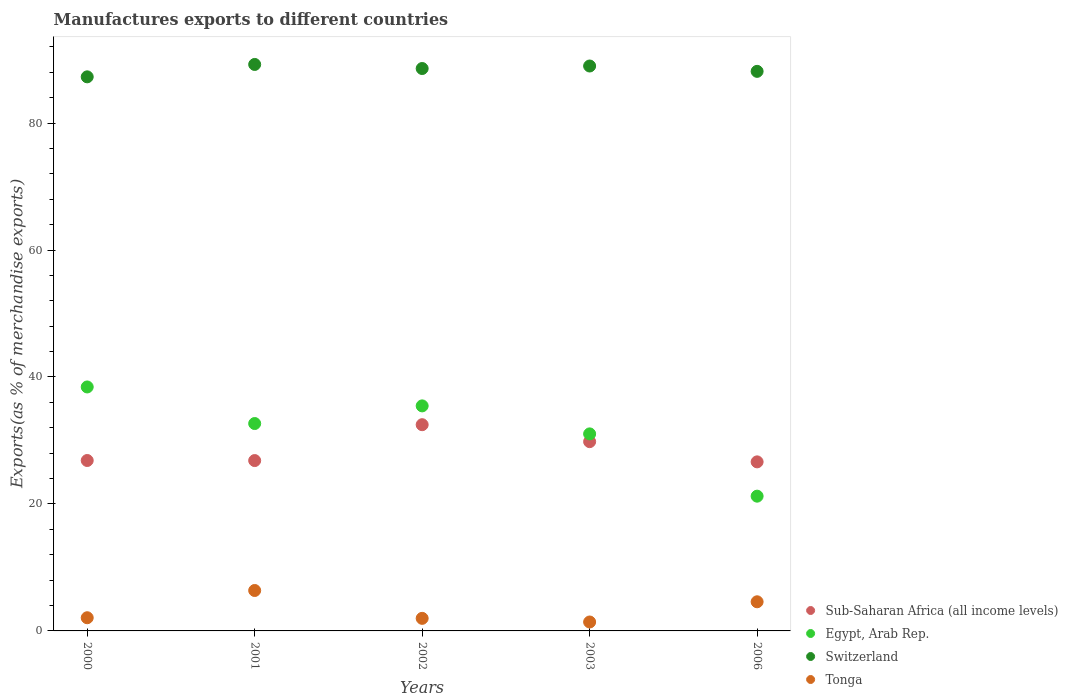How many different coloured dotlines are there?
Make the answer very short. 4. Is the number of dotlines equal to the number of legend labels?
Your response must be concise. Yes. What is the percentage of exports to different countries in Egypt, Arab Rep. in 2000?
Offer a terse response. 38.43. Across all years, what is the maximum percentage of exports to different countries in Tonga?
Offer a terse response. 6.37. Across all years, what is the minimum percentage of exports to different countries in Sub-Saharan Africa (all income levels)?
Provide a short and direct response. 26.63. In which year was the percentage of exports to different countries in Sub-Saharan Africa (all income levels) maximum?
Offer a terse response. 2002. What is the total percentage of exports to different countries in Tonga in the graph?
Provide a succinct answer. 16.42. What is the difference between the percentage of exports to different countries in Sub-Saharan Africa (all income levels) in 2002 and that in 2006?
Ensure brevity in your answer.  5.85. What is the difference between the percentage of exports to different countries in Tonga in 2003 and the percentage of exports to different countries in Switzerland in 2000?
Make the answer very short. -85.87. What is the average percentage of exports to different countries in Tonga per year?
Provide a succinct answer. 3.28. In the year 2003, what is the difference between the percentage of exports to different countries in Egypt, Arab Rep. and percentage of exports to different countries in Switzerland?
Your answer should be very brief. -57.95. In how many years, is the percentage of exports to different countries in Sub-Saharan Africa (all income levels) greater than 36 %?
Offer a very short reply. 0. What is the ratio of the percentage of exports to different countries in Switzerland in 2000 to that in 2003?
Your answer should be compact. 0.98. Is the difference between the percentage of exports to different countries in Egypt, Arab Rep. in 2001 and 2002 greater than the difference between the percentage of exports to different countries in Switzerland in 2001 and 2002?
Provide a short and direct response. No. What is the difference between the highest and the second highest percentage of exports to different countries in Sub-Saharan Africa (all income levels)?
Keep it short and to the point. 2.67. What is the difference between the highest and the lowest percentage of exports to different countries in Egypt, Arab Rep.?
Offer a very short reply. 17.2. In how many years, is the percentage of exports to different countries in Sub-Saharan Africa (all income levels) greater than the average percentage of exports to different countries in Sub-Saharan Africa (all income levels) taken over all years?
Make the answer very short. 2. Is the sum of the percentage of exports to different countries in Switzerland in 2000 and 2002 greater than the maximum percentage of exports to different countries in Sub-Saharan Africa (all income levels) across all years?
Give a very brief answer. Yes. Is it the case that in every year, the sum of the percentage of exports to different countries in Egypt, Arab Rep. and percentage of exports to different countries in Sub-Saharan Africa (all income levels)  is greater than the percentage of exports to different countries in Tonga?
Make the answer very short. Yes. Is the percentage of exports to different countries in Sub-Saharan Africa (all income levels) strictly less than the percentage of exports to different countries in Tonga over the years?
Make the answer very short. No. Are the values on the major ticks of Y-axis written in scientific E-notation?
Ensure brevity in your answer.  No. Does the graph contain any zero values?
Provide a succinct answer. No. Does the graph contain grids?
Ensure brevity in your answer.  No. What is the title of the graph?
Offer a terse response. Manufactures exports to different countries. What is the label or title of the X-axis?
Keep it short and to the point. Years. What is the label or title of the Y-axis?
Your answer should be very brief. Exports(as % of merchandise exports). What is the Exports(as % of merchandise exports) of Sub-Saharan Africa (all income levels) in 2000?
Provide a succinct answer. 26.84. What is the Exports(as % of merchandise exports) in Egypt, Arab Rep. in 2000?
Make the answer very short. 38.43. What is the Exports(as % of merchandise exports) in Switzerland in 2000?
Offer a very short reply. 87.28. What is the Exports(as % of merchandise exports) in Tonga in 2000?
Ensure brevity in your answer.  2.08. What is the Exports(as % of merchandise exports) of Sub-Saharan Africa (all income levels) in 2001?
Ensure brevity in your answer.  26.83. What is the Exports(as % of merchandise exports) in Egypt, Arab Rep. in 2001?
Offer a terse response. 32.67. What is the Exports(as % of merchandise exports) in Switzerland in 2001?
Offer a very short reply. 89.23. What is the Exports(as % of merchandise exports) of Tonga in 2001?
Ensure brevity in your answer.  6.37. What is the Exports(as % of merchandise exports) of Sub-Saharan Africa (all income levels) in 2002?
Your answer should be very brief. 32.48. What is the Exports(as % of merchandise exports) in Egypt, Arab Rep. in 2002?
Give a very brief answer. 35.45. What is the Exports(as % of merchandise exports) of Switzerland in 2002?
Keep it short and to the point. 88.59. What is the Exports(as % of merchandise exports) in Tonga in 2002?
Make the answer very short. 1.98. What is the Exports(as % of merchandise exports) in Sub-Saharan Africa (all income levels) in 2003?
Keep it short and to the point. 29.81. What is the Exports(as % of merchandise exports) of Egypt, Arab Rep. in 2003?
Your response must be concise. 31.04. What is the Exports(as % of merchandise exports) in Switzerland in 2003?
Offer a very short reply. 88.98. What is the Exports(as % of merchandise exports) in Tonga in 2003?
Offer a terse response. 1.41. What is the Exports(as % of merchandise exports) in Sub-Saharan Africa (all income levels) in 2006?
Your answer should be very brief. 26.63. What is the Exports(as % of merchandise exports) of Egypt, Arab Rep. in 2006?
Make the answer very short. 21.23. What is the Exports(as % of merchandise exports) in Switzerland in 2006?
Offer a terse response. 88.14. What is the Exports(as % of merchandise exports) in Tonga in 2006?
Keep it short and to the point. 4.59. Across all years, what is the maximum Exports(as % of merchandise exports) of Sub-Saharan Africa (all income levels)?
Make the answer very short. 32.48. Across all years, what is the maximum Exports(as % of merchandise exports) in Egypt, Arab Rep.?
Your answer should be compact. 38.43. Across all years, what is the maximum Exports(as % of merchandise exports) in Switzerland?
Provide a short and direct response. 89.23. Across all years, what is the maximum Exports(as % of merchandise exports) of Tonga?
Provide a succinct answer. 6.37. Across all years, what is the minimum Exports(as % of merchandise exports) of Sub-Saharan Africa (all income levels)?
Provide a short and direct response. 26.63. Across all years, what is the minimum Exports(as % of merchandise exports) of Egypt, Arab Rep.?
Give a very brief answer. 21.23. Across all years, what is the minimum Exports(as % of merchandise exports) in Switzerland?
Give a very brief answer. 87.28. Across all years, what is the minimum Exports(as % of merchandise exports) of Tonga?
Give a very brief answer. 1.41. What is the total Exports(as % of merchandise exports) of Sub-Saharan Africa (all income levels) in the graph?
Ensure brevity in your answer.  142.6. What is the total Exports(as % of merchandise exports) in Egypt, Arab Rep. in the graph?
Give a very brief answer. 158.81. What is the total Exports(as % of merchandise exports) in Switzerland in the graph?
Give a very brief answer. 442.22. What is the total Exports(as % of merchandise exports) in Tonga in the graph?
Make the answer very short. 16.42. What is the difference between the Exports(as % of merchandise exports) of Sub-Saharan Africa (all income levels) in 2000 and that in 2001?
Your answer should be very brief. 0.01. What is the difference between the Exports(as % of merchandise exports) of Egypt, Arab Rep. in 2000 and that in 2001?
Give a very brief answer. 5.76. What is the difference between the Exports(as % of merchandise exports) of Switzerland in 2000 and that in 2001?
Your answer should be very brief. -1.95. What is the difference between the Exports(as % of merchandise exports) of Tonga in 2000 and that in 2001?
Ensure brevity in your answer.  -4.29. What is the difference between the Exports(as % of merchandise exports) of Sub-Saharan Africa (all income levels) in 2000 and that in 2002?
Your response must be concise. -5.64. What is the difference between the Exports(as % of merchandise exports) of Egypt, Arab Rep. in 2000 and that in 2002?
Provide a short and direct response. 2.98. What is the difference between the Exports(as % of merchandise exports) in Switzerland in 2000 and that in 2002?
Offer a very short reply. -1.31. What is the difference between the Exports(as % of merchandise exports) of Tonga in 2000 and that in 2002?
Keep it short and to the point. 0.1. What is the difference between the Exports(as % of merchandise exports) of Sub-Saharan Africa (all income levels) in 2000 and that in 2003?
Offer a terse response. -2.97. What is the difference between the Exports(as % of merchandise exports) of Egypt, Arab Rep. in 2000 and that in 2003?
Give a very brief answer. 7.39. What is the difference between the Exports(as % of merchandise exports) in Switzerland in 2000 and that in 2003?
Your answer should be very brief. -1.71. What is the difference between the Exports(as % of merchandise exports) of Tonga in 2000 and that in 2003?
Your response must be concise. 0.67. What is the difference between the Exports(as % of merchandise exports) in Sub-Saharan Africa (all income levels) in 2000 and that in 2006?
Your answer should be compact. 0.22. What is the difference between the Exports(as % of merchandise exports) of Egypt, Arab Rep. in 2000 and that in 2006?
Give a very brief answer. 17.2. What is the difference between the Exports(as % of merchandise exports) in Switzerland in 2000 and that in 2006?
Your answer should be very brief. -0.86. What is the difference between the Exports(as % of merchandise exports) in Tonga in 2000 and that in 2006?
Offer a terse response. -2.51. What is the difference between the Exports(as % of merchandise exports) of Sub-Saharan Africa (all income levels) in 2001 and that in 2002?
Provide a short and direct response. -5.65. What is the difference between the Exports(as % of merchandise exports) of Egypt, Arab Rep. in 2001 and that in 2002?
Keep it short and to the point. -2.78. What is the difference between the Exports(as % of merchandise exports) of Switzerland in 2001 and that in 2002?
Your answer should be very brief. 0.64. What is the difference between the Exports(as % of merchandise exports) in Tonga in 2001 and that in 2002?
Your response must be concise. 4.39. What is the difference between the Exports(as % of merchandise exports) of Sub-Saharan Africa (all income levels) in 2001 and that in 2003?
Your answer should be very brief. -2.98. What is the difference between the Exports(as % of merchandise exports) in Egypt, Arab Rep. in 2001 and that in 2003?
Offer a very short reply. 1.63. What is the difference between the Exports(as % of merchandise exports) in Switzerland in 2001 and that in 2003?
Your answer should be very brief. 0.24. What is the difference between the Exports(as % of merchandise exports) of Tonga in 2001 and that in 2003?
Offer a very short reply. 4.96. What is the difference between the Exports(as % of merchandise exports) of Sub-Saharan Africa (all income levels) in 2001 and that in 2006?
Make the answer very short. 0.2. What is the difference between the Exports(as % of merchandise exports) of Egypt, Arab Rep. in 2001 and that in 2006?
Your answer should be compact. 11.44. What is the difference between the Exports(as % of merchandise exports) of Switzerland in 2001 and that in 2006?
Provide a short and direct response. 1.09. What is the difference between the Exports(as % of merchandise exports) in Tonga in 2001 and that in 2006?
Offer a terse response. 1.78. What is the difference between the Exports(as % of merchandise exports) in Sub-Saharan Africa (all income levels) in 2002 and that in 2003?
Your answer should be compact. 2.67. What is the difference between the Exports(as % of merchandise exports) in Egypt, Arab Rep. in 2002 and that in 2003?
Your response must be concise. 4.41. What is the difference between the Exports(as % of merchandise exports) of Switzerland in 2002 and that in 2003?
Your answer should be very brief. -0.4. What is the difference between the Exports(as % of merchandise exports) in Tonga in 2002 and that in 2003?
Provide a short and direct response. 0.57. What is the difference between the Exports(as % of merchandise exports) in Sub-Saharan Africa (all income levels) in 2002 and that in 2006?
Ensure brevity in your answer.  5.85. What is the difference between the Exports(as % of merchandise exports) in Egypt, Arab Rep. in 2002 and that in 2006?
Your response must be concise. 14.22. What is the difference between the Exports(as % of merchandise exports) in Switzerland in 2002 and that in 2006?
Offer a very short reply. 0.45. What is the difference between the Exports(as % of merchandise exports) in Tonga in 2002 and that in 2006?
Give a very brief answer. -2.61. What is the difference between the Exports(as % of merchandise exports) in Sub-Saharan Africa (all income levels) in 2003 and that in 2006?
Provide a short and direct response. 3.18. What is the difference between the Exports(as % of merchandise exports) of Egypt, Arab Rep. in 2003 and that in 2006?
Your answer should be compact. 9.81. What is the difference between the Exports(as % of merchandise exports) in Switzerland in 2003 and that in 2006?
Your answer should be compact. 0.84. What is the difference between the Exports(as % of merchandise exports) in Tonga in 2003 and that in 2006?
Ensure brevity in your answer.  -3.18. What is the difference between the Exports(as % of merchandise exports) of Sub-Saharan Africa (all income levels) in 2000 and the Exports(as % of merchandise exports) of Egypt, Arab Rep. in 2001?
Make the answer very short. -5.82. What is the difference between the Exports(as % of merchandise exports) in Sub-Saharan Africa (all income levels) in 2000 and the Exports(as % of merchandise exports) in Switzerland in 2001?
Offer a terse response. -62.38. What is the difference between the Exports(as % of merchandise exports) in Sub-Saharan Africa (all income levels) in 2000 and the Exports(as % of merchandise exports) in Tonga in 2001?
Give a very brief answer. 20.48. What is the difference between the Exports(as % of merchandise exports) of Egypt, Arab Rep. in 2000 and the Exports(as % of merchandise exports) of Switzerland in 2001?
Your response must be concise. -50.8. What is the difference between the Exports(as % of merchandise exports) of Egypt, Arab Rep. in 2000 and the Exports(as % of merchandise exports) of Tonga in 2001?
Your answer should be compact. 32.06. What is the difference between the Exports(as % of merchandise exports) in Switzerland in 2000 and the Exports(as % of merchandise exports) in Tonga in 2001?
Provide a succinct answer. 80.91. What is the difference between the Exports(as % of merchandise exports) in Sub-Saharan Africa (all income levels) in 2000 and the Exports(as % of merchandise exports) in Egypt, Arab Rep. in 2002?
Offer a terse response. -8.6. What is the difference between the Exports(as % of merchandise exports) of Sub-Saharan Africa (all income levels) in 2000 and the Exports(as % of merchandise exports) of Switzerland in 2002?
Ensure brevity in your answer.  -61.74. What is the difference between the Exports(as % of merchandise exports) in Sub-Saharan Africa (all income levels) in 2000 and the Exports(as % of merchandise exports) in Tonga in 2002?
Your answer should be very brief. 24.87. What is the difference between the Exports(as % of merchandise exports) in Egypt, Arab Rep. in 2000 and the Exports(as % of merchandise exports) in Switzerland in 2002?
Offer a very short reply. -50.16. What is the difference between the Exports(as % of merchandise exports) in Egypt, Arab Rep. in 2000 and the Exports(as % of merchandise exports) in Tonga in 2002?
Offer a very short reply. 36.45. What is the difference between the Exports(as % of merchandise exports) of Switzerland in 2000 and the Exports(as % of merchandise exports) of Tonga in 2002?
Give a very brief answer. 85.3. What is the difference between the Exports(as % of merchandise exports) of Sub-Saharan Africa (all income levels) in 2000 and the Exports(as % of merchandise exports) of Egypt, Arab Rep. in 2003?
Give a very brief answer. -4.19. What is the difference between the Exports(as % of merchandise exports) in Sub-Saharan Africa (all income levels) in 2000 and the Exports(as % of merchandise exports) in Switzerland in 2003?
Offer a very short reply. -62.14. What is the difference between the Exports(as % of merchandise exports) of Sub-Saharan Africa (all income levels) in 2000 and the Exports(as % of merchandise exports) of Tonga in 2003?
Provide a short and direct response. 25.44. What is the difference between the Exports(as % of merchandise exports) in Egypt, Arab Rep. in 2000 and the Exports(as % of merchandise exports) in Switzerland in 2003?
Provide a short and direct response. -50.56. What is the difference between the Exports(as % of merchandise exports) of Egypt, Arab Rep. in 2000 and the Exports(as % of merchandise exports) of Tonga in 2003?
Provide a short and direct response. 37.02. What is the difference between the Exports(as % of merchandise exports) of Switzerland in 2000 and the Exports(as % of merchandise exports) of Tonga in 2003?
Offer a terse response. 85.87. What is the difference between the Exports(as % of merchandise exports) in Sub-Saharan Africa (all income levels) in 2000 and the Exports(as % of merchandise exports) in Egypt, Arab Rep. in 2006?
Your answer should be very brief. 5.62. What is the difference between the Exports(as % of merchandise exports) of Sub-Saharan Africa (all income levels) in 2000 and the Exports(as % of merchandise exports) of Switzerland in 2006?
Your response must be concise. -61.3. What is the difference between the Exports(as % of merchandise exports) of Sub-Saharan Africa (all income levels) in 2000 and the Exports(as % of merchandise exports) of Tonga in 2006?
Give a very brief answer. 22.26. What is the difference between the Exports(as % of merchandise exports) in Egypt, Arab Rep. in 2000 and the Exports(as % of merchandise exports) in Switzerland in 2006?
Provide a succinct answer. -49.71. What is the difference between the Exports(as % of merchandise exports) of Egypt, Arab Rep. in 2000 and the Exports(as % of merchandise exports) of Tonga in 2006?
Ensure brevity in your answer.  33.84. What is the difference between the Exports(as % of merchandise exports) of Switzerland in 2000 and the Exports(as % of merchandise exports) of Tonga in 2006?
Your answer should be very brief. 82.69. What is the difference between the Exports(as % of merchandise exports) in Sub-Saharan Africa (all income levels) in 2001 and the Exports(as % of merchandise exports) in Egypt, Arab Rep. in 2002?
Offer a terse response. -8.61. What is the difference between the Exports(as % of merchandise exports) of Sub-Saharan Africa (all income levels) in 2001 and the Exports(as % of merchandise exports) of Switzerland in 2002?
Offer a terse response. -61.76. What is the difference between the Exports(as % of merchandise exports) of Sub-Saharan Africa (all income levels) in 2001 and the Exports(as % of merchandise exports) of Tonga in 2002?
Offer a very short reply. 24.85. What is the difference between the Exports(as % of merchandise exports) in Egypt, Arab Rep. in 2001 and the Exports(as % of merchandise exports) in Switzerland in 2002?
Keep it short and to the point. -55.92. What is the difference between the Exports(as % of merchandise exports) in Egypt, Arab Rep. in 2001 and the Exports(as % of merchandise exports) in Tonga in 2002?
Keep it short and to the point. 30.69. What is the difference between the Exports(as % of merchandise exports) in Switzerland in 2001 and the Exports(as % of merchandise exports) in Tonga in 2002?
Provide a succinct answer. 87.25. What is the difference between the Exports(as % of merchandise exports) of Sub-Saharan Africa (all income levels) in 2001 and the Exports(as % of merchandise exports) of Egypt, Arab Rep. in 2003?
Offer a very short reply. -4.2. What is the difference between the Exports(as % of merchandise exports) in Sub-Saharan Africa (all income levels) in 2001 and the Exports(as % of merchandise exports) in Switzerland in 2003?
Offer a terse response. -62.15. What is the difference between the Exports(as % of merchandise exports) of Sub-Saharan Africa (all income levels) in 2001 and the Exports(as % of merchandise exports) of Tonga in 2003?
Your response must be concise. 25.43. What is the difference between the Exports(as % of merchandise exports) of Egypt, Arab Rep. in 2001 and the Exports(as % of merchandise exports) of Switzerland in 2003?
Give a very brief answer. -56.32. What is the difference between the Exports(as % of merchandise exports) in Egypt, Arab Rep. in 2001 and the Exports(as % of merchandise exports) in Tonga in 2003?
Your response must be concise. 31.26. What is the difference between the Exports(as % of merchandise exports) in Switzerland in 2001 and the Exports(as % of merchandise exports) in Tonga in 2003?
Keep it short and to the point. 87.82. What is the difference between the Exports(as % of merchandise exports) in Sub-Saharan Africa (all income levels) in 2001 and the Exports(as % of merchandise exports) in Egypt, Arab Rep. in 2006?
Offer a terse response. 5.61. What is the difference between the Exports(as % of merchandise exports) of Sub-Saharan Africa (all income levels) in 2001 and the Exports(as % of merchandise exports) of Switzerland in 2006?
Give a very brief answer. -61.31. What is the difference between the Exports(as % of merchandise exports) of Sub-Saharan Africa (all income levels) in 2001 and the Exports(as % of merchandise exports) of Tonga in 2006?
Provide a short and direct response. 22.24. What is the difference between the Exports(as % of merchandise exports) of Egypt, Arab Rep. in 2001 and the Exports(as % of merchandise exports) of Switzerland in 2006?
Your answer should be very brief. -55.47. What is the difference between the Exports(as % of merchandise exports) in Egypt, Arab Rep. in 2001 and the Exports(as % of merchandise exports) in Tonga in 2006?
Give a very brief answer. 28.08. What is the difference between the Exports(as % of merchandise exports) in Switzerland in 2001 and the Exports(as % of merchandise exports) in Tonga in 2006?
Make the answer very short. 84.64. What is the difference between the Exports(as % of merchandise exports) in Sub-Saharan Africa (all income levels) in 2002 and the Exports(as % of merchandise exports) in Egypt, Arab Rep. in 2003?
Offer a very short reply. 1.45. What is the difference between the Exports(as % of merchandise exports) in Sub-Saharan Africa (all income levels) in 2002 and the Exports(as % of merchandise exports) in Switzerland in 2003?
Offer a very short reply. -56.5. What is the difference between the Exports(as % of merchandise exports) in Sub-Saharan Africa (all income levels) in 2002 and the Exports(as % of merchandise exports) in Tonga in 2003?
Offer a very short reply. 31.08. What is the difference between the Exports(as % of merchandise exports) in Egypt, Arab Rep. in 2002 and the Exports(as % of merchandise exports) in Switzerland in 2003?
Offer a terse response. -53.54. What is the difference between the Exports(as % of merchandise exports) of Egypt, Arab Rep. in 2002 and the Exports(as % of merchandise exports) of Tonga in 2003?
Give a very brief answer. 34.04. What is the difference between the Exports(as % of merchandise exports) in Switzerland in 2002 and the Exports(as % of merchandise exports) in Tonga in 2003?
Keep it short and to the point. 87.18. What is the difference between the Exports(as % of merchandise exports) in Sub-Saharan Africa (all income levels) in 2002 and the Exports(as % of merchandise exports) in Egypt, Arab Rep. in 2006?
Your answer should be very brief. 11.26. What is the difference between the Exports(as % of merchandise exports) in Sub-Saharan Africa (all income levels) in 2002 and the Exports(as % of merchandise exports) in Switzerland in 2006?
Provide a succinct answer. -55.66. What is the difference between the Exports(as % of merchandise exports) of Sub-Saharan Africa (all income levels) in 2002 and the Exports(as % of merchandise exports) of Tonga in 2006?
Offer a terse response. 27.89. What is the difference between the Exports(as % of merchandise exports) in Egypt, Arab Rep. in 2002 and the Exports(as % of merchandise exports) in Switzerland in 2006?
Give a very brief answer. -52.69. What is the difference between the Exports(as % of merchandise exports) in Egypt, Arab Rep. in 2002 and the Exports(as % of merchandise exports) in Tonga in 2006?
Offer a very short reply. 30.86. What is the difference between the Exports(as % of merchandise exports) of Switzerland in 2002 and the Exports(as % of merchandise exports) of Tonga in 2006?
Your answer should be compact. 84. What is the difference between the Exports(as % of merchandise exports) in Sub-Saharan Africa (all income levels) in 2003 and the Exports(as % of merchandise exports) in Egypt, Arab Rep. in 2006?
Your answer should be compact. 8.59. What is the difference between the Exports(as % of merchandise exports) of Sub-Saharan Africa (all income levels) in 2003 and the Exports(as % of merchandise exports) of Switzerland in 2006?
Your answer should be compact. -58.33. What is the difference between the Exports(as % of merchandise exports) in Sub-Saharan Africa (all income levels) in 2003 and the Exports(as % of merchandise exports) in Tonga in 2006?
Ensure brevity in your answer.  25.22. What is the difference between the Exports(as % of merchandise exports) in Egypt, Arab Rep. in 2003 and the Exports(as % of merchandise exports) in Switzerland in 2006?
Provide a short and direct response. -57.1. What is the difference between the Exports(as % of merchandise exports) of Egypt, Arab Rep. in 2003 and the Exports(as % of merchandise exports) of Tonga in 2006?
Keep it short and to the point. 26.45. What is the difference between the Exports(as % of merchandise exports) of Switzerland in 2003 and the Exports(as % of merchandise exports) of Tonga in 2006?
Offer a very short reply. 84.39. What is the average Exports(as % of merchandise exports) in Sub-Saharan Africa (all income levels) per year?
Offer a terse response. 28.52. What is the average Exports(as % of merchandise exports) in Egypt, Arab Rep. per year?
Offer a terse response. 31.76. What is the average Exports(as % of merchandise exports) of Switzerland per year?
Offer a very short reply. 88.44. What is the average Exports(as % of merchandise exports) in Tonga per year?
Make the answer very short. 3.28. In the year 2000, what is the difference between the Exports(as % of merchandise exports) of Sub-Saharan Africa (all income levels) and Exports(as % of merchandise exports) of Egypt, Arab Rep.?
Make the answer very short. -11.58. In the year 2000, what is the difference between the Exports(as % of merchandise exports) of Sub-Saharan Africa (all income levels) and Exports(as % of merchandise exports) of Switzerland?
Offer a very short reply. -60.43. In the year 2000, what is the difference between the Exports(as % of merchandise exports) in Sub-Saharan Africa (all income levels) and Exports(as % of merchandise exports) in Tonga?
Keep it short and to the point. 24.77. In the year 2000, what is the difference between the Exports(as % of merchandise exports) of Egypt, Arab Rep. and Exports(as % of merchandise exports) of Switzerland?
Your response must be concise. -48.85. In the year 2000, what is the difference between the Exports(as % of merchandise exports) of Egypt, Arab Rep. and Exports(as % of merchandise exports) of Tonga?
Ensure brevity in your answer.  36.35. In the year 2000, what is the difference between the Exports(as % of merchandise exports) of Switzerland and Exports(as % of merchandise exports) of Tonga?
Ensure brevity in your answer.  85.2. In the year 2001, what is the difference between the Exports(as % of merchandise exports) in Sub-Saharan Africa (all income levels) and Exports(as % of merchandise exports) in Egypt, Arab Rep.?
Make the answer very short. -5.83. In the year 2001, what is the difference between the Exports(as % of merchandise exports) of Sub-Saharan Africa (all income levels) and Exports(as % of merchandise exports) of Switzerland?
Your answer should be very brief. -62.4. In the year 2001, what is the difference between the Exports(as % of merchandise exports) of Sub-Saharan Africa (all income levels) and Exports(as % of merchandise exports) of Tonga?
Offer a terse response. 20.47. In the year 2001, what is the difference between the Exports(as % of merchandise exports) in Egypt, Arab Rep. and Exports(as % of merchandise exports) in Switzerland?
Your response must be concise. -56.56. In the year 2001, what is the difference between the Exports(as % of merchandise exports) of Egypt, Arab Rep. and Exports(as % of merchandise exports) of Tonga?
Your answer should be very brief. 26.3. In the year 2001, what is the difference between the Exports(as % of merchandise exports) in Switzerland and Exports(as % of merchandise exports) in Tonga?
Offer a terse response. 82.86. In the year 2002, what is the difference between the Exports(as % of merchandise exports) in Sub-Saharan Africa (all income levels) and Exports(as % of merchandise exports) in Egypt, Arab Rep.?
Your answer should be very brief. -2.96. In the year 2002, what is the difference between the Exports(as % of merchandise exports) in Sub-Saharan Africa (all income levels) and Exports(as % of merchandise exports) in Switzerland?
Ensure brevity in your answer.  -56.1. In the year 2002, what is the difference between the Exports(as % of merchandise exports) of Sub-Saharan Africa (all income levels) and Exports(as % of merchandise exports) of Tonga?
Your answer should be compact. 30.5. In the year 2002, what is the difference between the Exports(as % of merchandise exports) in Egypt, Arab Rep. and Exports(as % of merchandise exports) in Switzerland?
Provide a succinct answer. -53.14. In the year 2002, what is the difference between the Exports(as % of merchandise exports) in Egypt, Arab Rep. and Exports(as % of merchandise exports) in Tonga?
Provide a short and direct response. 33.47. In the year 2002, what is the difference between the Exports(as % of merchandise exports) in Switzerland and Exports(as % of merchandise exports) in Tonga?
Your answer should be very brief. 86.61. In the year 2003, what is the difference between the Exports(as % of merchandise exports) in Sub-Saharan Africa (all income levels) and Exports(as % of merchandise exports) in Egypt, Arab Rep.?
Make the answer very short. -1.22. In the year 2003, what is the difference between the Exports(as % of merchandise exports) in Sub-Saharan Africa (all income levels) and Exports(as % of merchandise exports) in Switzerland?
Offer a very short reply. -59.17. In the year 2003, what is the difference between the Exports(as % of merchandise exports) in Sub-Saharan Africa (all income levels) and Exports(as % of merchandise exports) in Tonga?
Offer a very short reply. 28.41. In the year 2003, what is the difference between the Exports(as % of merchandise exports) of Egypt, Arab Rep. and Exports(as % of merchandise exports) of Switzerland?
Your response must be concise. -57.95. In the year 2003, what is the difference between the Exports(as % of merchandise exports) in Egypt, Arab Rep. and Exports(as % of merchandise exports) in Tonga?
Provide a succinct answer. 29.63. In the year 2003, what is the difference between the Exports(as % of merchandise exports) of Switzerland and Exports(as % of merchandise exports) of Tonga?
Offer a very short reply. 87.58. In the year 2006, what is the difference between the Exports(as % of merchandise exports) of Sub-Saharan Africa (all income levels) and Exports(as % of merchandise exports) of Egypt, Arab Rep.?
Offer a very short reply. 5.4. In the year 2006, what is the difference between the Exports(as % of merchandise exports) in Sub-Saharan Africa (all income levels) and Exports(as % of merchandise exports) in Switzerland?
Your answer should be very brief. -61.51. In the year 2006, what is the difference between the Exports(as % of merchandise exports) in Sub-Saharan Africa (all income levels) and Exports(as % of merchandise exports) in Tonga?
Your answer should be very brief. 22.04. In the year 2006, what is the difference between the Exports(as % of merchandise exports) of Egypt, Arab Rep. and Exports(as % of merchandise exports) of Switzerland?
Your answer should be compact. -66.91. In the year 2006, what is the difference between the Exports(as % of merchandise exports) in Egypt, Arab Rep. and Exports(as % of merchandise exports) in Tonga?
Your answer should be compact. 16.64. In the year 2006, what is the difference between the Exports(as % of merchandise exports) of Switzerland and Exports(as % of merchandise exports) of Tonga?
Keep it short and to the point. 83.55. What is the ratio of the Exports(as % of merchandise exports) in Sub-Saharan Africa (all income levels) in 2000 to that in 2001?
Your answer should be very brief. 1. What is the ratio of the Exports(as % of merchandise exports) in Egypt, Arab Rep. in 2000 to that in 2001?
Provide a short and direct response. 1.18. What is the ratio of the Exports(as % of merchandise exports) in Switzerland in 2000 to that in 2001?
Provide a short and direct response. 0.98. What is the ratio of the Exports(as % of merchandise exports) in Tonga in 2000 to that in 2001?
Make the answer very short. 0.33. What is the ratio of the Exports(as % of merchandise exports) in Sub-Saharan Africa (all income levels) in 2000 to that in 2002?
Provide a succinct answer. 0.83. What is the ratio of the Exports(as % of merchandise exports) of Egypt, Arab Rep. in 2000 to that in 2002?
Make the answer very short. 1.08. What is the ratio of the Exports(as % of merchandise exports) in Switzerland in 2000 to that in 2002?
Offer a very short reply. 0.99. What is the ratio of the Exports(as % of merchandise exports) of Tonga in 2000 to that in 2002?
Offer a very short reply. 1.05. What is the ratio of the Exports(as % of merchandise exports) of Sub-Saharan Africa (all income levels) in 2000 to that in 2003?
Offer a very short reply. 0.9. What is the ratio of the Exports(as % of merchandise exports) of Egypt, Arab Rep. in 2000 to that in 2003?
Offer a terse response. 1.24. What is the ratio of the Exports(as % of merchandise exports) of Switzerland in 2000 to that in 2003?
Your response must be concise. 0.98. What is the ratio of the Exports(as % of merchandise exports) of Tonga in 2000 to that in 2003?
Provide a succinct answer. 1.48. What is the ratio of the Exports(as % of merchandise exports) of Egypt, Arab Rep. in 2000 to that in 2006?
Offer a very short reply. 1.81. What is the ratio of the Exports(as % of merchandise exports) in Switzerland in 2000 to that in 2006?
Your answer should be compact. 0.99. What is the ratio of the Exports(as % of merchandise exports) in Tonga in 2000 to that in 2006?
Provide a succinct answer. 0.45. What is the ratio of the Exports(as % of merchandise exports) of Sub-Saharan Africa (all income levels) in 2001 to that in 2002?
Make the answer very short. 0.83. What is the ratio of the Exports(as % of merchandise exports) of Egypt, Arab Rep. in 2001 to that in 2002?
Provide a short and direct response. 0.92. What is the ratio of the Exports(as % of merchandise exports) in Switzerland in 2001 to that in 2002?
Your response must be concise. 1.01. What is the ratio of the Exports(as % of merchandise exports) of Tonga in 2001 to that in 2002?
Offer a very short reply. 3.22. What is the ratio of the Exports(as % of merchandise exports) in Sub-Saharan Africa (all income levels) in 2001 to that in 2003?
Ensure brevity in your answer.  0.9. What is the ratio of the Exports(as % of merchandise exports) of Egypt, Arab Rep. in 2001 to that in 2003?
Offer a very short reply. 1.05. What is the ratio of the Exports(as % of merchandise exports) in Switzerland in 2001 to that in 2003?
Your answer should be very brief. 1. What is the ratio of the Exports(as % of merchandise exports) of Tonga in 2001 to that in 2003?
Provide a succinct answer. 4.53. What is the ratio of the Exports(as % of merchandise exports) of Sub-Saharan Africa (all income levels) in 2001 to that in 2006?
Provide a short and direct response. 1.01. What is the ratio of the Exports(as % of merchandise exports) of Egypt, Arab Rep. in 2001 to that in 2006?
Provide a succinct answer. 1.54. What is the ratio of the Exports(as % of merchandise exports) in Switzerland in 2001 to that in 2006?
Offer a terse response. 1.01. What is the ratio of the Exports(as % of merchandise exports) in Tonga in 2001 to that in 2006?
Give a very brief answer. 1.39. What is the ratio of the Exports(as % of merchandise exports) in Sub-Saharan Africa (all income levels) in 2002 to that in 2003?
Your answer should be very brief. 1.09. What is the ratio of the Exports(as % of merchandise exports) in Egypt, Arab Rep. in 2002 to that in 2003?
Keep it short and to the point. 1.14. What is the ratio of the Exports(as % of merchandise exports) of Switzerland in 2002 to that in 2003?
Provide a short and direct response. 1. What is the ratio of the Exports(as % of merchandise exports) in Tonga in 2002 to that in 2003?
Your answer should be compact. 1.41. What is the ratio of the Exports(as % of merchandise exports) of Sub-Saharan Africa (all income levels) in 2002 to that in 2006?
Provide a succinct answer. 1.22. What is the ratio of the Exports(as % of merchandise exports) in Egypt, Arab Rep. in 2002 to that in 2006?
Your answer should be very brief. 1.67. What is the ratio of the Exports(as % of merchandise exports) of Tonga in 2002 to that in 2006?
Provide a succinct answer. 0.43. What is the ratio of the Exports(as % of merchandise exports) in Sub-Saharan Africa (all income levels) in 2003 to that in 2006?
Provide a short and direct response. 1.12. What is the ratio of the Exports(as % of merchandise exports) of Egypt, Arab Rep. in 2003 to that in 2006?
Make the answer very short. 1.46. What is the ratio of the Exports(as % of merchandise exports) of Switzerland in 2003 to that in 2006?
Make the answer very short. 1.01. What is the ratio of the Exports(as % of merchandise exports) in Tonga in 2003 to that in 2006?
Your answer should be very brief. 0.31. What is the difference between the highest and the second highest Exports(as % of merchandise exports) of Sub-Saharan Africa (all income levels)?
Make the answer very short. 2.67. What is the difference between the highest and the second highest Exports(as % of merchandise exports) of Egypt, Arab Rep.?
Offer a terse response. 2.98. What is the difference between the highest and the second highest Exports(as % of merchandise exports) of Switzerland?
Offer a terse response. 0.24. What is the difference between the highest and the second highest Exports(as % of merchandise exports) in Tonga?
Provide a succinct answer. 1.78. What is the difference between the highest and the lowest Exports(as % of merchandise exports) of Sub-Saharan Africa (all income levels)?
Your response must be concise. 5.85. What is the difference between the highest and the lowest Exports(as % of merchandise exports) in Egypt, Arab Rep.?
Give a very brief answer. 17.2. What is the difference between the highest and the lowest Exports(as % of merchandise exports) in Switzerland?
Your answer should be very brief. 1.95. What is the difference between the highest and the lowest Exports(as % of merchandise exports) of Tonga?
Your answer should be very brief. 4.96. 